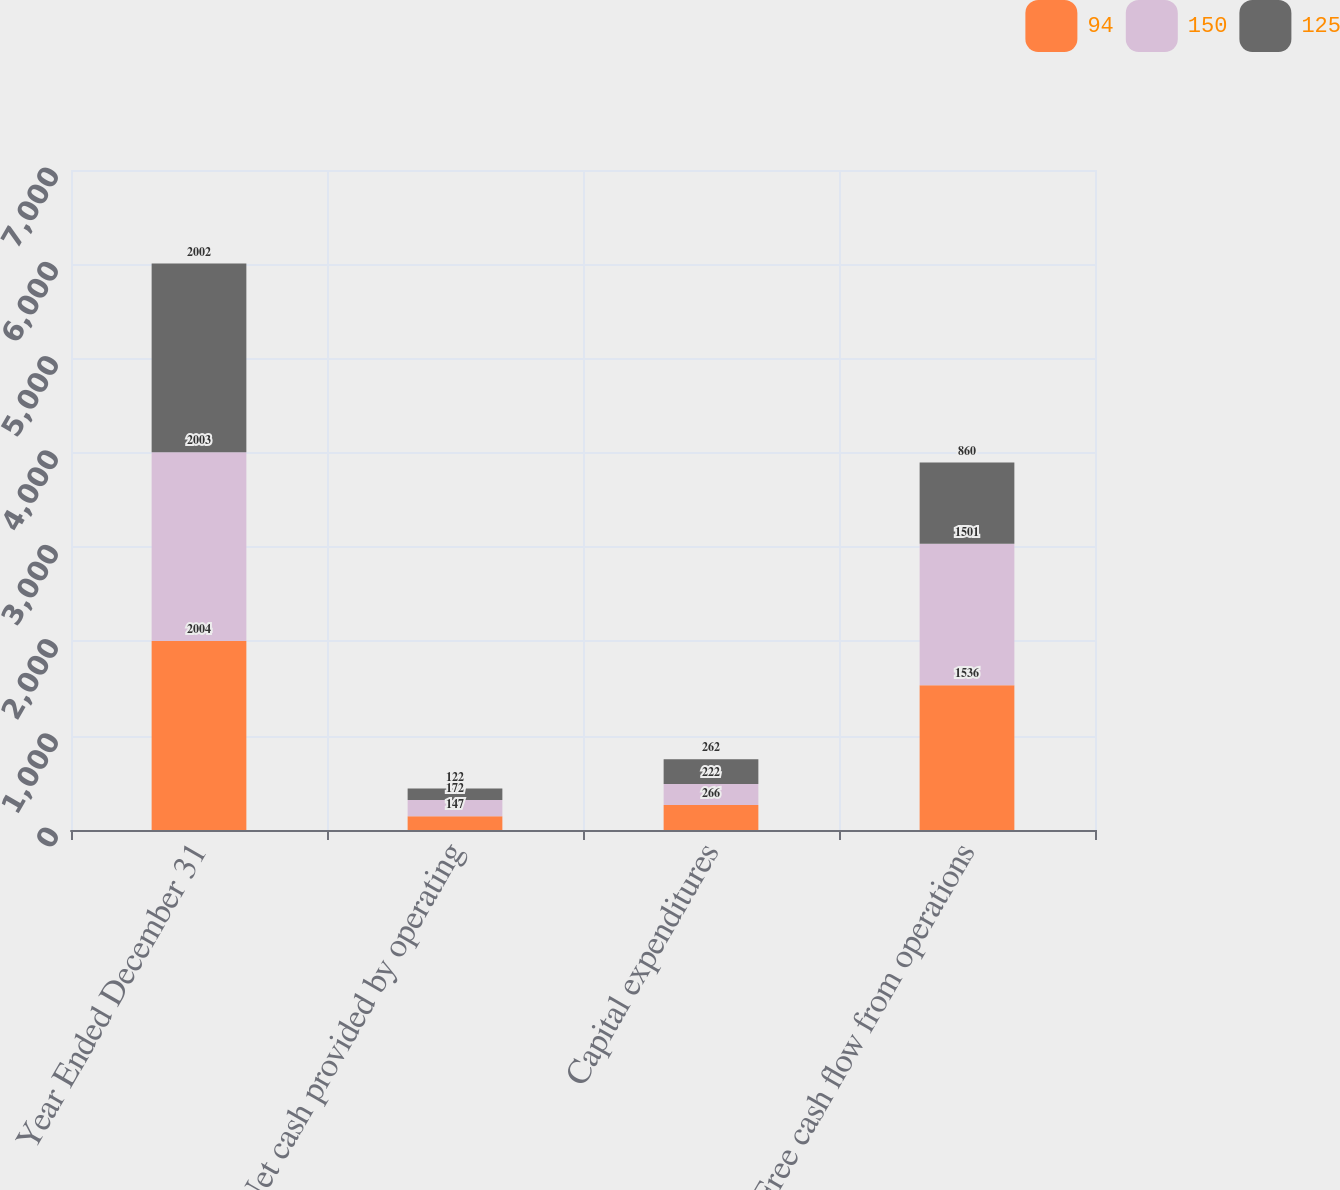<chart> <loc_0><loc_0><loc_500><loc_500><stacked_bar_chart><ecel><fcel>Year Ended December 31<fcel>Net cash provided by operating<fcel>Capital expenditures<fcel>Free cash flow from operations<nl><fcel>94<fcel>2004<fcel>147<fcel>266<fcel>1536<nl><fcel>150<fcel>2003<fcel>172<fcel>222<fcel>1501<nl><fcel>125<fcel>2002<fcel>122<fcel>262<fcel>860<nl></chart> 